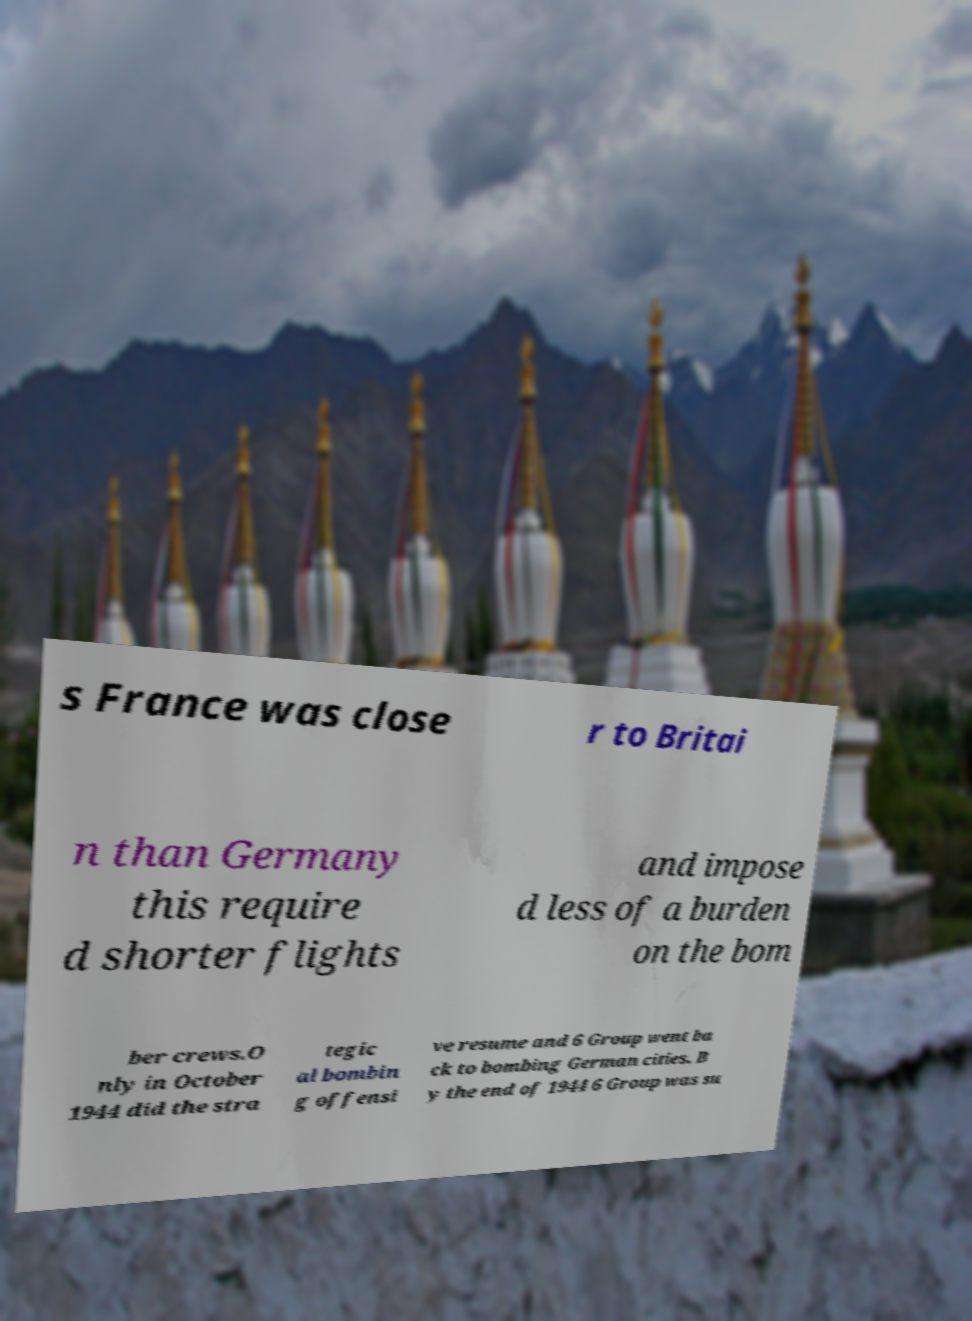What messages or text are displayed in this image? I need them in a readable, typed format. s France was close r to Britai n than Germany this require d shorter flights and impose d less of a burden on the bom ber crews.O nly in October 1944 did the stra tegic al bombin g offensi ve resume and 6 Group went ba ck to bombing German cities. B y the end of 1944 6 Group was su 